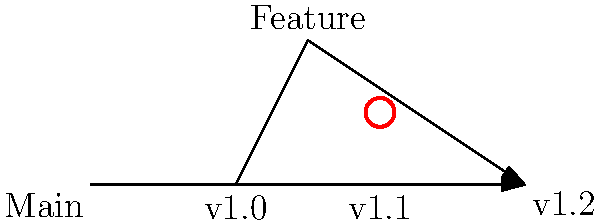In the Medusa version control branching diagram, a conflict is indicated at the merge point between the Feature branch and the main branch. What is the most efficient approach to resolve this conflict while ensuring data integrity in the Medusa data model? To resolve the conflict in the Medusa version control branching diagram while maintaining data integrity, follow these steps:

1. Identify the conflict: The red circle indicates a conflict at the merge point between the Feature branch and the main branch (v1.1).

2. Analyze the conflicting changes:
   a. Review the changes made in the Feature branch.
   b. Examine the changes made in the main branch (v1.0 to v1.1).

3. Use Medusa's built-in conflict resolution tools:
   a. Open the Medusa conflict resolution interface.
   b. Compare the conflicting versions side by side.

4. Resolve the conflict:
   a. Manually merge the changes, ensuring that the data model integrity is maintained.
   b. If necessary, consult with the development team to determine which changes should take precedence.

5. Validate the merged result:
   a. Run Medusa's data model validation tools to ensure the merged version maintains data integrity.
   b. Address any warnings or errors reported by the validation tools.

6. Commit the resolved version:
   a. Once the conflict is resolved and validated, commit the changes.
   b. Provide a clear commit message explaining the conflict resolution.

7. Update the Feature branch:
   a. Merge the resolved changes back into the Feature branch.
   b. Ensure the Feature branch is now in sync with the main branch.

8. Continue the merge process:
   a. Complete the merge of the Feature branch into the main branch (v1.2).
   b. Conduct final testing to ensure the merged version functions correctly.

By following these steps, you can efficiently resolve the conflict while maintaining the integrity of the Medusa data model.
Answer: Manually merge changes, validate data model integrity, commit resolved version 